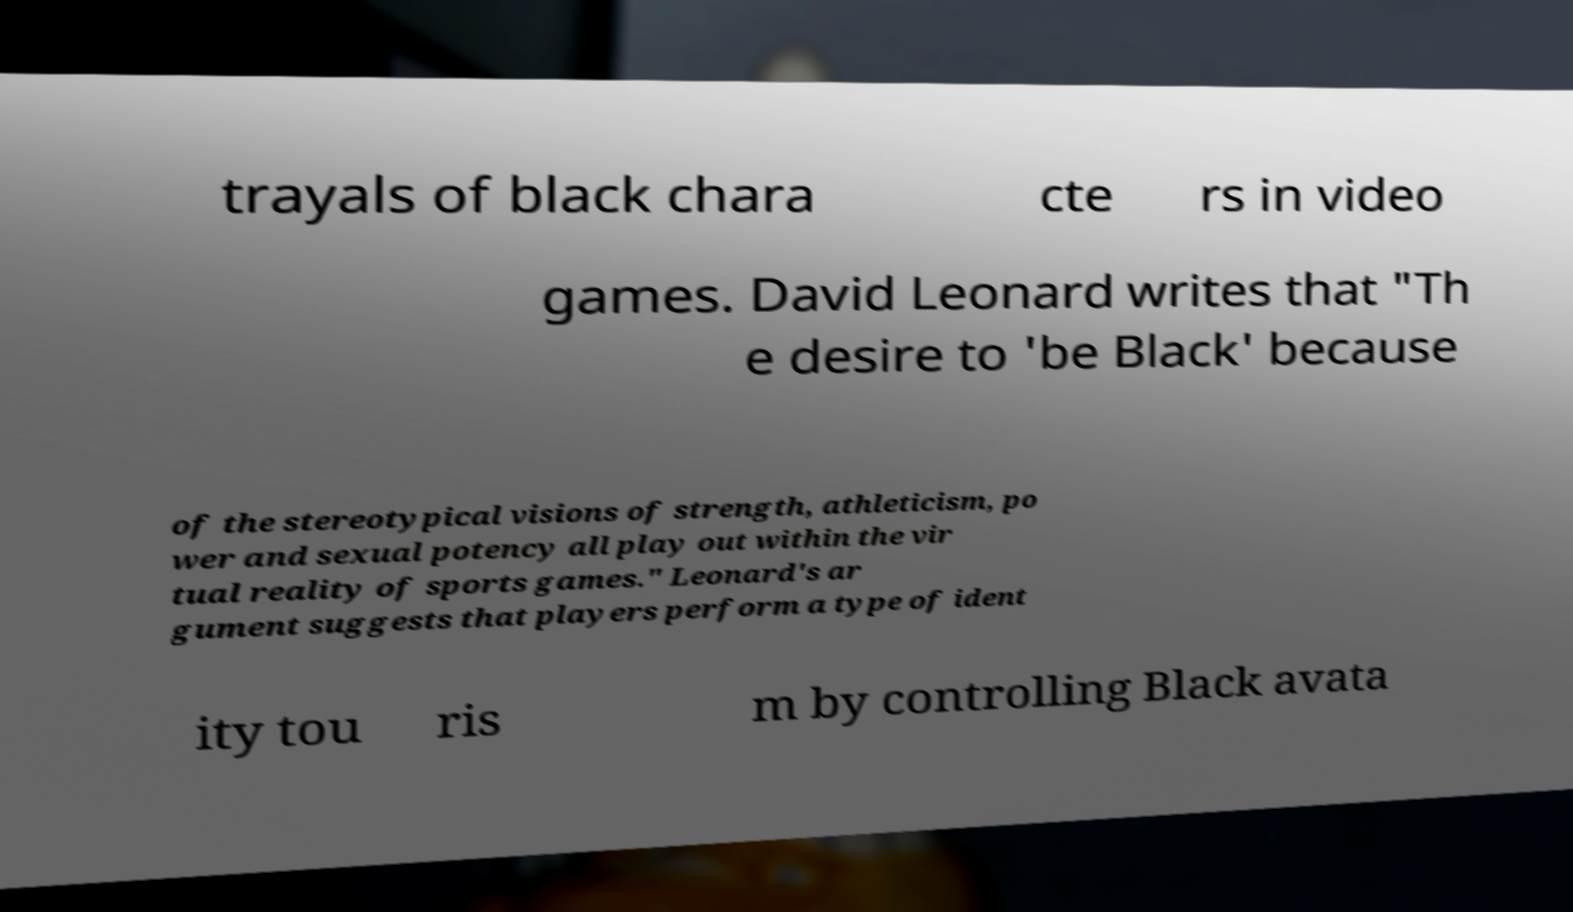Can you accurately transcribe the text from the provided image for me? trayals of black chara cte rs in video games. David Leonard writes that "Th e desire to 'be Black' because of the stereotypical visions of strength, athleticism, po wer and sexual potency all play out within the vir tual reality of sports games." Leonard's ar gument suggests that players perform a type of ident ity tou ris m by controlling Black avata 